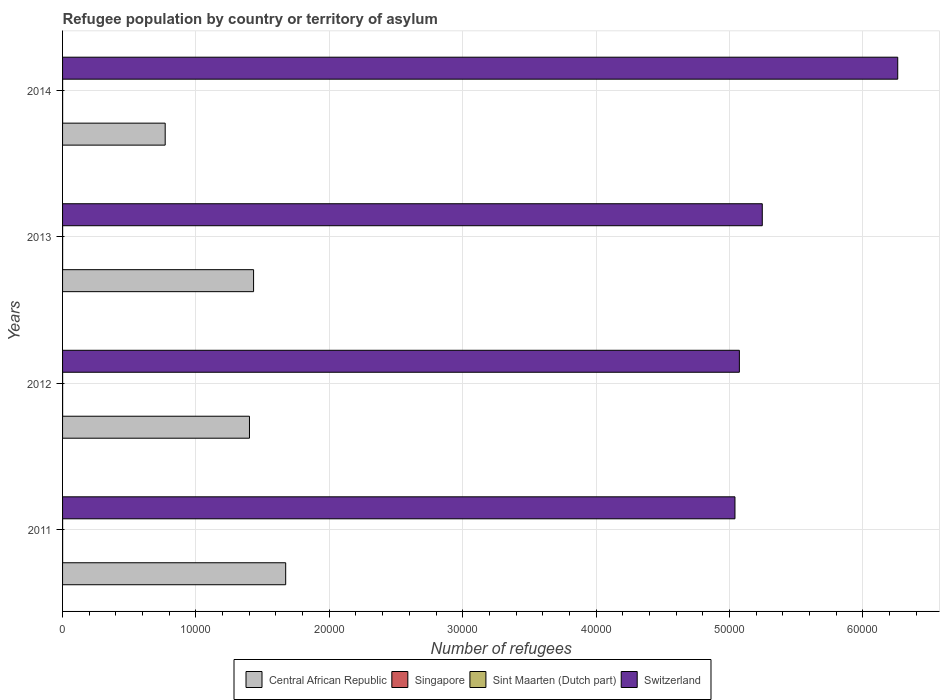How many groups of bars are there?
Your response must be concise. 4. Are the number of bars per tick equal to the number of legend labels?
Keep it short and to the point. Yes. Are the number of bars on each tick of the Y-axis equal?
Your response must be concise. Yes. How many bars are there on the 4th tick from the bottom?
Keep it short and to the point. 4. What is the label of the 1st group of bars from the top?
Make the answer very short. 2014. In how many cases, is the number of bars for a given year not equal to the number of legend labels?
Make the answer very short. 0. Across all years, what is the maximum number of refugees in Switzerland?
Your response must be concise. 6.26e+04. Across all years, what is the minimum number of refugees in Sint Maarten (Dutch part)?
Keep it short and to the point. 3. What is the total number of refugees in Switzerland in the graph?
Offer a very short reply. 2.16e+05. What is the difference between the number of refugees in Sint Maarten (Dutch part) in 2013 and that in 2014?
Your answer should be compact. 0. What is the difference between the number of refugees in Central African Republic in 2014 and the number of refugees in Sint Maarten (Dutch part) in 2012?
Make the answer very short. 7691. What is the average number of refugees in Sint Maarten (Dutch part) per year?
Your answer should be compact. 3. In the year 2013, what is the difference between the number of refugees in Singapore and number of refugees in Switzerland?
Provide a succinct answer. -5.25e+04. Is the number of refugees in Central African Republic in 2013 less than that in 2014?
Keep it short and to the point. No. Is the difference between the number of refugees in Singapore in 2012 and 2013 greater than the difference between the number of refugees in Switzerland in 2012 and 2013?
Your response must be concise. Yes. What is the difference between the highest and the second highest number of refugees in Sint Maarten (Dutch part)?
Your answer should be compact. 0. What is the difference between the highest and the lowest number of refugees in Central African Republic?
Provide a succinct answer. 9036. Is the sum of the number of refugees in Singapore in 2012 and 2013 greater than the maximum number of refugees in Sint Maarten (Dutch part) across all years?
Offer a terse response. Yes. What does the 3rd bar from the top in 2014 represents?
Keep it short and to the point. Singapore. What does the 3rd bar from the bottom in 2012 represents?
Offer a very short reply. Sint Maarten (Dutch part). How many years are there in the graph?
Your answer should be compact. 4. What is the difference between two consecutive major ticks on the X-axis?
Keep it short and to the point. 10000. Are the values on the major ticks of X-axis written in scientific E-notation?
Ensure brevity in your answer.  No. How many legend labels are there?
Provide a succinct answer. 4. What is the title of the graph?
Provide a succinct answer. Refugee population by country or territory of asylum. Does "San Marino" appear as one of the legend labels in the graph?
Your answer should be compact. No. What is the label or title of the X-axis?
Your answer should be compact. Number of refugees. What is the label or title of the Y-axis?
Provide a short and direct response. Years. What is the Number of refugees of Central African Republic in 2011?
Offer a terse response. 1.67e+04. What is the Number of refugees of Switzerland in 2011?
Provide a succinct answer. 5.04e+04. What is the Number of refugees in Central African Republic in 2012?
Keep it short and to the point. 1.40e+04. What is the Number of refugees in Singapore in 2012?
Offer a very short reply. 3. What is the Number of refugees in Switzerland in 2012?
Offer a very short reply. 5.07e+04. What is the Number of refugees in Central African Republic in 2013?
Keep it short and to the point. 1.43e+04. What is the Number of refugees of Singapore in 2013?
Provide a succinct answer. 3. What is the Number of refugees of Switzerland in 2013?
Your response must be concise. 5.25e+04. What is the Number of refugees of Central African Republic in 2014?
Keep it short and to the point. 7694. What is the Number of refugees in Switzerland in 2014?
Provide a short and direct response. 6.26e+04. Across all years, what is the maximum Number of refugees in Central African Republic?
Your answer should be very brief. 1.67e+04. Across all years, what is the maximum Number of refugees of Singapore?
Offer a terse response. 3. Across all years, what is the maximum Number of refugees in Sint Maarten (Dutch part)?
Provide a short and direct response. 3. Across all years, what is the maximum Number of refugees in Switzerland?
Keep it short and to the point. 6.26e+04. Across all years, what is the minimum Number of refugees of Central African Republic?
Provide a short and direct response. 7694. Across all years, what is the minimum Number of refugees in Singapore?
Your response must be concise. 3. Across all years, what is the minimum Number of refugees in Switzerland?
Make the answer very short. 5.04e+04. What is the total Number of refugees of Central African Republic in the graph?
Give a very brief answer. 5.28e+04. What is the total Number of refugees in Singapore in the graph?
Offer a terse response. 12. What is the total Number of refugees in Switzerland in the graph?
Make the answer very short. 2.16e+05. What is the difference between the Number of refugees of Central African Republic in 2011 and that in 2012?
Your answer should be compact. 2716. What is the difference between the Number of refugees in Singapore in 2011 and that in 2012?
Offer a very short reply. 0. What is the difference between the Number of refugees of Switzerland in 2011 and that in 2012?
Offer a very short reply. -331. What is the difference between the Number of refugees in Central African Republic in 2011 and that in 2013?
Provide a succinct answer. 2408. What is the difference between the Number of refugees of Singapore in 2011 and that in 2013?
Provide a short and direct response. 0. What is the difference between the Number of refugees in Switzerland in 2011 and that in 2013?
Provide a short and direct response. -2048. What is the difference between the Number of refugees of Central African Republic in 2011 and that in 2014?
Your answer should be compact. 9036. What is the difference between the Number of refugees of Sint Maarten (Dutch part) in 2011 and that in 2014?
Give a very brief answer. 0. What is the difference between the Number of refugees of Switzerland in 2011 and that in 2014?
Provide a succinct answer. -1.22e+04. What is the difference between the Number of refugees in Central African Republic in 2012 and that in 2013?
Provide a short and direct response. -308. What is the difference between the Number of refugees of Sint Maarten (Dutch part) in 2012 and that in 2013?
Offer a very short reply. 0. What is the difference between the Number of refugees of Switzerland in 2012 and that in 2013?
Offer a terse response. -1717. What is the difference between the Number of refugees in Central African Republic in 2012 and that in 2014?
Offer a terse response. 6320. What is the difference between the Number of refugees in Singapore in 2012 and that in 2014?
Offer a very short reply. 0. What is the difference between the Number of refugees in Switzerland in 2012 and that in 2014?
Give a very brief answer. -1.19e+04. What is the difference between the Number of refugees of Central African Republic in 2013 and that in 2014?
Provide a succinct answer. 6628. What is the difference between the Number of refugees of Sint Maarten (Dutch part) in 2013 and that in 2014?
Give a very brief answer. 0. What is the difference between the Number of refugees in Switzerland in 2013 and that in 2014?
Keep it short and to the point. -1.02e+04. What is the difference between the Number of refugees of Central African Republic in 2011 and the Number of refugees of Singapore in 2012?
Make the answer very short. 1.67e+04. What is the difference between the Number of refugees of Central African Republic in 2011 and the Number of refugees of Sint Maarten (Dutch part) in 2012?
Offer a terse response. 1.67e+04. What is the difference between the Number of refugees of Central African Republic in 2011 and the Number of refugees of Switzerland in 2012?
Give a very brief answer. -3.40e+04. What is the difference between the Number of refugees in Singapore in 2011 and the Number of refugees in Sint Maarten (Dutch part) in 2012?
Offer a terse response. 0. What is the difference between the Number of refugees of Singapore in 2011 and the Number of refugees of Switzerland in 2012?
Your answer should be compact. -5.07e+04. What is the difference between the Number of refugees in Sint Maarten (Dutch part) in 2011 and the Number of refugees in Switzerland in 2012?
Give a very brief answer. -5.07e+04. What is the difference between the Number of refugees of Central African Republic in 2011 and the Number of refugees of Singapore in 2013?
Ensure brevity in your answer.  1.67e+04. What is the difference between the Number of refugees of Central African Republic in 2011 and the Number of refugees of Sint Maarten (Dutch part) in 2013?
Your answer should be very brief. 1.67e+04. What is the difference between the Number of refugees in Central African Republic in 2011 and the Number of refugees in Switzerland in 2013?
Provide a short and direct response. -3.57e+04. What is the difference between the Number of refugees of Singapore in 2011 and the Number of refugees of Sint Maarten (Dutch part) in 2013?
Provide a succinct answer. 0. What is the difference between the Number of refugees in Singapore in 2011 and the Number of refugees in Switzerland in 2013?
Make the answer very short. -5.25e+04. What is the difference between the Number of refugees in Sint Maarten (Dutch part) in 2011 and the Number of refugees in Switzerland in 2013?
Offer a very short reply. -5.25e+04. What is the difference between the Number of refugees in Central African Republic in 2011 and the Number of refugees in Singapore in 2014?
Provide a succinct answer. 1.67e+04. What is the difference between the Number of refugees of Central African Republic in 2011 and the Number of refugees of Sint Maarten (Dutch part) in 2014?
Make the answer very short. 1.67e+04. What is the difference between the Number of refugees in Central African Republic in 2011 and the Number of refugees in Switzerland in 2014?
Your answer should be very brief. -4.59e+04. What is the difference between the Number of refugees in Singapore in 2011 and the Number of refugees in Sint Maarten (Dutch part) in 2014?
Offer a very short reply. 0. What is the difference between the Number of refugees of Singapore in 2011 and the Number of refugees of Switzerland in 2014?
Provide a short and direct response. -6.26e+04. What is the difference between the Number of refugees of Sint Maarten (Dutch part) in 2011 and the Number of refugees of Switzerland in 2014?
Ensure brevity in your answer.  -6.26e+04. What is the difference between the Number of refugees in Central African Republic in 2012 and the Number of refugees in Singapore in 2013?
Provide a succinct answer. 1.40e+04. What is the difference between the Number of refugees in Central African Republic in 2012 and the Number of refugees in Sint Maarten (Dutch part) in 2013?
Offer a very short reply. 1.40e+04. What is the difference between the Number of refugees in Central African Republic in 2012 and the Number of refugees in Switzerland in 2013?
Provide a short and direct response. -3.84e+04. What is the difference between the Number of refugees of Singapore in 2012 and the Number of refugees of Switzerland in 2013?
Offer a terse response. -5.25e+04. What is the difference between the Number of refugees in Sint Maarten (Dutch part) in 2012 and the Number of refugees in Switzerland in 2013?
Provide a short and direct response. -5.25e+04. What is the difference between the Number of refugees of Central African Republic in 2012 and the Number of refugees of Singapore in 2014?
Ensure brevity in your answer.  1.40e+04. What is the difference between the Number of refugees of Central African Republic in 2012 and the Number of refugees of Sint Maarten (Dutch part) in 2014?
Make the answer very short. 1.40e+04. What is the difference between the Number of refugees of Central African Republic in 2012 and the Number of refugees of Switzerland in 2014?
Make the answer very short. -4.86e+04. What is the difference between the Number of refugees in Singapore in 2012 and the Number of refugees in Sint Maarten (Dutch part) in 2014?
Your response must be concise. 0. What is the difference between the Number of refugees in Singapore in 2012 and the Number of refugees in Switzerland in 2014?
Make the answer very short. -6.26e+04. What is the difference between the Number of refugees of Sint Maarten (Dutch part) in 2012 and the Number of refugees of Switzerland in 2014?
Ensure brevity in your answer.  -6.26e+04. What is the difference between the Number of refugees of Central African Republic in 2013 and the Number of refugees of Singapore in 2014?
Give a very brief answer. 1.43e+04. What is the difference between the Number of refugees in Central African Republic in 2013 and the Number of refugees in Sint Maarten (Dutch part) in 2014?
Give a very brief answer. 1.43e+04. What is the difference between the Number of refugees of Central African Republic in 2013 and the Number of refugees of Switzerland in 2014?
Provide a succinct answer. -4.83e+04. What is the difference between the Number of refugees of Singapore in 2013 and the Number of refugees of Switzerland in 2014?
Ensure brevity in your answer.  -6.26e+04. What is the difference between the Number of refugees in Sint Maarten (Dutch part) in 2013 and the Number of refugees in Switzerland in 2014?
Offer a very short reply. -6.26e+04. What is the average Number of refugees of Central African Republic per year?
Offer a terse response. 1.32e+04. What is the average Number of refugees in Sint Maarten (Dutch part) per year?
Keep it short and to the point. 3. What is the average Number of refugees in Switzerland per year?
Offer a very short reply. 5.41e+04. In the year 2011, what is the difference between the Number of refugees in Central African Republic and Number of refugees in Singapore?
Provide a short and direct response. 1.67e+04. In the year 2011, what is the difference between the Number of refugees of Central African Republic and Number of refugees of Sint Maarten (Dutch part)?
Offer a terse response. 1.67e+04. In the year 2011, what is the difference between the Number of refugees of Central African Republic and Number of refugees of Switzerland?
Give a very brief answer. -3.37e+04. In the year 2011, what is the difference between the Number of refugees in Singapore and Number of refugees in Switzerland?
Give a very brief answer. -5.04e+04. In the year 2011, what is the difference between the Number of refugees in Sint Maarten (Dutch part) and Number of refugees in Switzerland?
Offer a very short reply. -5.04e+04. In the year 2012, what is the difference between the Number of refugees in Central African Republic and Number of refugees in Singapore?
Your answer should be very brief. 1.40e+04. In the year 2012, what is the difference between the Number of refugees of Central African Republic and Number of refugees of Sint Maarten (Dutch part)?
Ensure brevity in your answer.  1.40e+04. In the year 2012, what is the difference between the Number of refugees in Central African Republic and Number of refugees in Switzerland?
Offer a very short reply. -3.67e+04. In the year 2012, what is the difference between the Number of refugees in Singapore and Number of refugees in Switzerland?
Your response must be concise. -5.07e+04. In the year 2012, what is the difference between the Number of refugees of Sint Maarten (Dutch part) and Number of refugees of Switzerland?
Ensure brevity in your answer.  -5.07e+04. In the year 2013, what is the difference between the Number of refugees in Central African Republic and Number of refugees in Singapore?
Give a very brief answer. 1.43e+04. In the year 2013, what is the difference between the Number of refugees in Central African Republic and Number of refugees in Sint Maarten (Dutch part)?
Provide a succinct answer. 1.43e+04. In the year 2013, what is the difference between the Number of refugees in Central African Republic and Number of refugees in Switzerland?
Make the answer very short. -3.81e+04. In the year 2013, what is the difference between the Number of refugees of Singapore and Number of refugees of Switzerland?
Ensure brevity in your answer.  -5.25e+04. In the year 2013, what is the difference between the Number of refugees in Sint Maarten (Dutch part) and Number of refugees in Switzerland?
Offer a very short reply. -5.25e+04. In the year 2014, what is the difference between the Number of refugees of Central African Republic and Number of refugees of Singapore?
Ensure brevity in your answer.  7691. In the year 2014, what is the difference between the Number of refugees in Central African Republic and Number of refugees in Sint Maarten (Dutch part)?
Your response must be concise. 7691. In the year 2014, what is the difference between the Number of refugees of Central African Republic and Number of refugees of Switzerland?
Provide a short and direct response. -5.49e+04. In the year 2014, what is the difference between the Number of refugees in Singapore and Number of refugees in Switzerland?
Offer a very short reply. -6.26e+04. In the year 2014, what is the difference between the Number of refugees of Sint Maarten (Dutch part) and Number of refugees of Switzerland?
Your answer should be very brief. -6.26e+04. What is the ratio of the Number of refugees in Central African Republic in 2011 to that in 2012?
Keep it short and to the point. 1.19. What is the ratio of the Number of refugees in Singapore in 2011 to that in 2012?
Ensure brevity in your answer.  1. What is the ratio of the Number of refugees of Switzerland in 2011 to that in 2012?
Your answer should be compact. 0.99. What is the ratio of the Number of refugees in Central African Republic in 2011 to that in 2013?
Give a very brief answer. 1.17. What is the ratio of the Number of refugees in Singapore in 2011 to that in 2013?
Offer a terse response. 1. What is the ratio of the Number of refugees of Sint Maarten (Dutch part) in 2011 to that in 2013?
Provide a succinct answer. 1. What is the ratio of the Number of refugees in Central African Republic in 2011 to that in 2014?
Give a very brief answer. 2.17. What is the ratio of the Number of refugees of Switzerland in 2011 to that in 2014?
Offer a very short reply. 0.81. What is the ratio of the Number of refugees in Central African Republic in 2012 to that in 2013?
Your response must be concise. 0.98. What is the ratio of the Number of refugees in Sint Maarten (Dutch part) in 2012 to that in 2013?
Ensure brevity in your answer.  1. What is the ratio of the Number of refugees of Switzerland in 2012 to that in 2013?
Your answer should be compact. 0.97. What is the ratio of the Number of refugees in Central African Republic in 2012 to that in 2014?
Offer a very short reply. 1.82. What is the ratio of the Number of refugees in Singapore in 2012 to that in 2014?
Offer a terse response. 1. What is the ratio of the Number of refugees of Sint Maarten (Dutch part) in 2012 to that in 2014?
Provide a short and direct response. 1. What is the ratio of the Number of refugees in Switzerland in 2012 to that in 2014?
Provide a succinct answer. 0.81. What is the ratio of the Number of refugees in Central African Republic in 2013 to that in 2014?
Make the answer very short. 1.86. What is the ratio of the Number of refugees in Singapore in 2013 to that in 2014?
Provide a short and direct response. 1. What is the ratio of the Number of refugees in Switzerland in 2013 to that in 2014?
Make the answer very short. 0.84. What is the difference between the highest and the second highest Number of refugees of Central African Republic?
Offer a very short reply. 2408. What is the difference between the highest and the second highest Number of refugees of Sint Maarten (Dutch part)?
Your response must be concise. 0. What is the difference between the highest and the second highest Number of refugees of Switzerland?
Make the answer very short. 1.02e+04. What is the difference between the highest and the lowest Number of refugees of Central African Republic?
Your response must be concise. 9036. What is the difference between the highest and the lowest Number of refugees of Switzerland?
Your response must be concise. 1.22e+04. 